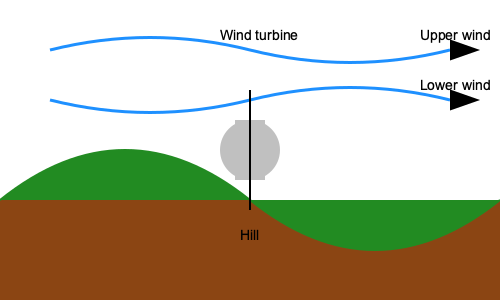Based on the diagram, which wind pattern is likely to provide more consistent and efficient energy production for the wind turbine, and why? To determine which wind pattern would provide more consistent and efficient energy production for the wind turbine, we need to consider the following factors:

1. Wind speed: Generally, higher wind speeds produce more energy.
2. Turbulence: Smooth, laminar flow is more efficient for wind turbines than turbulent flow.
3. Wind direction: Consistent wind direction is preferable for optimal turbine positioning.

Analyzing the diagram:

1. Upper wind pattern:
   - Flows smoothly over the hill
   - Maintains a consistent direction
   - Less affected by surface friction

2. Lower wind pattern:
   - Follows the contour of the hill
   - May experience more turbulence due to interaction with the terrain
   - More affected by surface friction, potentially reducing speed

3. Turbine position:
   - Located on top of the hill
   - Exposed to both upper and lower wind patterns

Given these observations, the upper wind pattern is likely to provide more consistent and efficient energy production because:

a) It maintains a smoother flow, reducing turbulence-induced stress on the turbine.
b) It is less affected by surface friction, potentially maintaining higher wind speeds.
c) Its consistent direction allows for optimal turbine positioning.

The lower wind pattern, while still useful, may be less efficient due to increased turbulence and potential speed reduction from surface interactions.
Answer: Upper wind pattern 